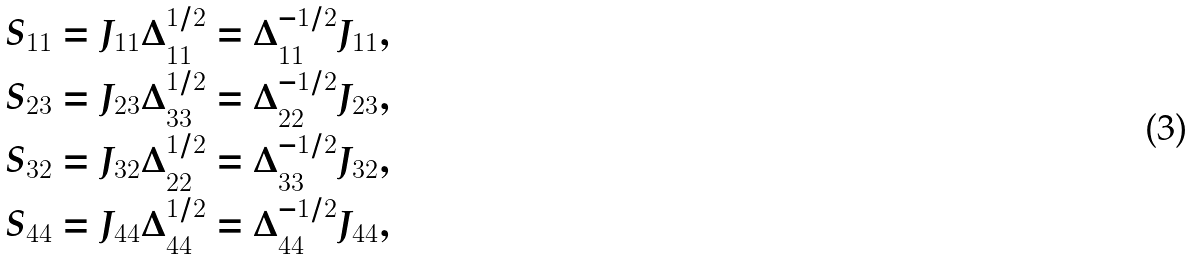Convert formula to latex. <formula><loc_0><loc_0><loc_500><loc_500>S _ { 1 1 } & = J _ { 1 1 } \Delta _ { 1 1 } ^ { 1 / 2 } = \Delta _ { 1 1 } ^ { - 1 / 2 } J _ { 1 1 } , \\ S _ { 2 3 } & = J _ { 2 3 } \Delta _ { 3 3 } ^ { 1 / 2 } = \Delta _ { 2 2 } ^ { - 1 / 2 } J _ { 2 3 } , \\ S _ { 3 2 } & = J _ { 3 2 } \Delta _ { 2 2 } ^ { 1 / 2 } = \Delta _ { 3 3 } ^ { - 1 / 2 } J _ { 3 2 } , \\ S _ { 4 4 } & = J _ { 4 4 } \Delta _ { 4 4 } ^ { 1 / 2 } = \Delta _ { 4 4 } ^ { - 1 / 2 } J _ { 4 4 } ,</formula> 